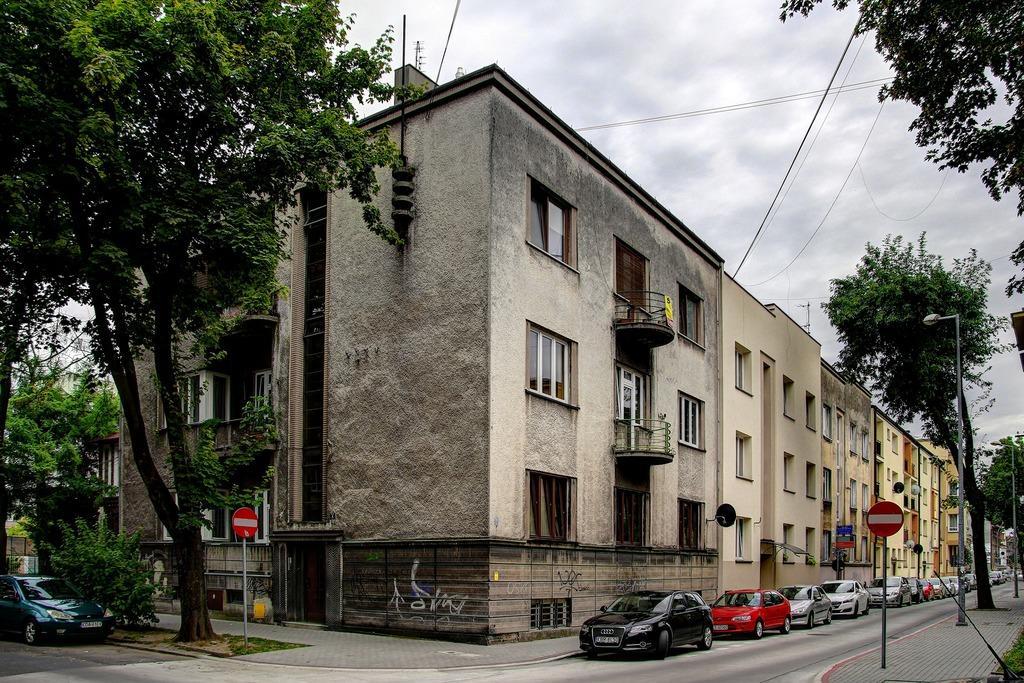Could you give a brief overview of what you see in this image? In this image, we can see some buildings. There are trees on the left and on the right side of the image. There is a road in between sign boards. There is a street pole in the bottom right of the image. There are some cars on the road. There is a sky and wires at the top of the image. 